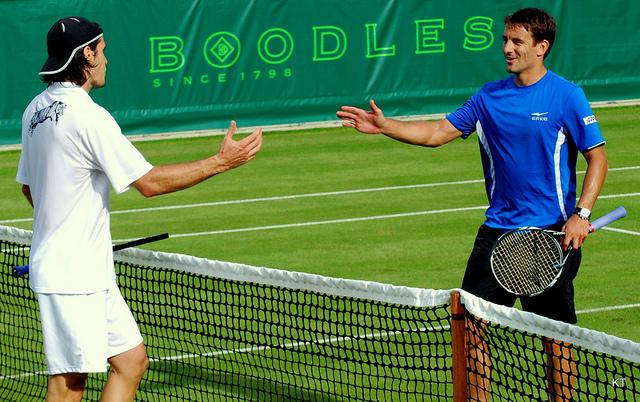What is the color of the pitch?
Concise answer only. Green. What is on his arm?
Give a very brief answer. Watch. Are they good sports?
Short answer required. Yes. Are they both wearing hats?
Quick response, please. No. What color is the man's shirt on the right?
Keep it brief. Blue. 